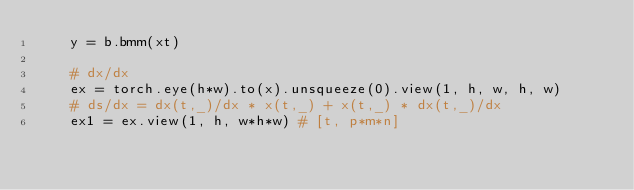<code> <loc_0><loc_0><loc_500><loc_500><_Python_>    y = b.bmm(xt)

    # dx/dx
    ex = torch.eye(h*w).to(x).unsqueeze(0).view(1, h, w, h, w)
    # ds/dx = dx(t,_)/dx * x(t,_) + x(t,_) * dx(t,_)/dx
    ex1 = ex.view(1, h, w*h*w) # [t, p*m*n]</code> 